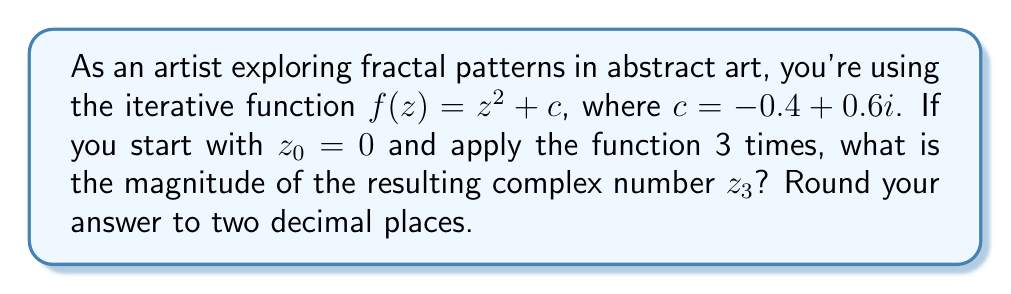Provide a solution to this math problem. Let's approach this step-by-step:

1) We start with $z_0 = 0$ and $c = -0.4 + 0.6i$

2) First iteration:
   $z_1 = f(z_0) = z_0^2 + c = 0^2 + (-0.4 + 0.6i) = -0.4 + 0.6i$

3) Second iteration:
   $z_2 = f(z_1) = z_1^2 + c$
   $= (-0.4 + 0.6i)^2 + (-0.4 + 0.6i)$
   $= (0.16 - 0.48i + 0.36i^2) + (-0.4 + 0.6i)$
   $= (0.16 - 0.48i - 0.36) + (-0.4 + 0.6i)$
   $= -0.6 + 0.12i$

4) Third iteration:
   $z_3 = f(z_2) = z_2^2 + c$
   $= (-0.6 + 0.12i)^2 + (-0.4 + 0.6i)$
   $= (0.36 - 0.144i + 0.0144i^2) + (-0.4 + 0.6i)$
   $= (0.36 - 0.144i - 0.0144) + (-0.4 + 0.6i)$
   $= -0.0544 + 0.456i$

5) To find the magnitude of $z_3$, we use the formula $|a+bi| = \sqrt{a^2 + b^2}$:
   $|z_3| = \sqrt{(-0.0544)^2 + (0.456)^2}$
   $= \sqrt{0.002959 + 0.207936}$
   $= \sqrt{0.210895}$
   $\approx 0.4592$

6) Rounding to two decimal places: 0.46
Answer: 0.46 